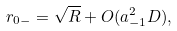<formula> <loc_0><loc_0><loc_500><loc_500>r _ { 0 - } = \sqrt { R } + O ( a _ { - 1 } ^ { 2 } D ) ,</formula> 